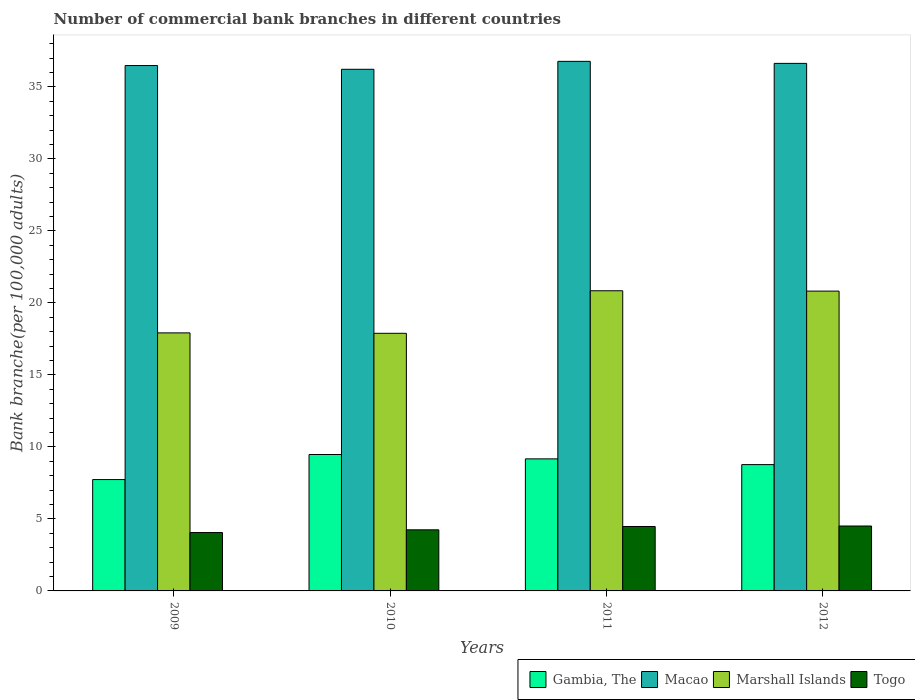How many different coloured bars are there?
Provide a succinct answer. 4. Are the number of bars per tick equal to the number of legend labels?
Your answer should be compact. Yes. How many bars are there on the 4th tick from the left?
Your response must be concise. 4. How many bars are there on the 1st tick from the right?
Give a very brief answer. 4. What is the label of the 4th group of bars from the left?
Make the answer very short. 2012. What is the number of commercial bank branches in Marshall Islands in 2009?
Provide a succinct answer. 17.92. Across all years, what is the maximum number of commercial bank branches in Macao?
Your answer should be compact. 36.77. Across all years, what is the minimum number of commercial bank branches in Marshall Islands?
Ensure brevity in your answer.  17.89. In which year was the number of commercial bank branches in Gambia, The maximum?
Make the answer very short. 2010. In which year was the number of commercial bank branches in Marshall Islands minimum?
Keep it short and to the point. 2010. What is the total number of commercial bank branches in Marshall Islands in the graph?
Provide a succinct answer. 77.46. What is the difference between the number of commercial bank branches in Macao in 2011 and that in 2012?
Your answer should be very brief. 0.14. What is the difference between the number of commercial bank branches in Macao in 2011 and the number of commercial bank branches in Togo in 2010?
Your response must be concise. 32.53. What is the average number of commercial bank branches in Gambia, The per year?
Offer a very short reply. 8.79. In the year 2012, what is the difference between the number of commercial bank branches in Macao and number of commercial bank branches in Marshall Islands?
Offer a very short reply. 15.81. In how many years, is the number of commercial bank branches in Gambia, The greater than 23?
Ensure brevity in your answer.  0. What is the ratio of the number of commercial bank branches in Marshall Islands in 2011 to that in 2012?
Offer a very short reply. 1. Is the number of commercial bank branches in Marshall Islands in 2011 less than that in 2012?
Offer a terse response. No. Is the difference between the number of commercial bank branches in Macao in 2010 and 2012 greater than the difference between the number of commercial bank branches in Marshall Islands in 2010 and 2012?
Offer a terse response. Yes. What is the difference between the highest and the second highest number of commercial bank branches in Macao?
Your answer should be compact. 0.14. What is the difference between the highest and the lowest number of commercial bank branches in Gambia, The?
Give a very brief answer. 1.74. Is the sum of the number of commercial bank branches in Togo in 2009 and 2011 greater than the maximum number of commercial bank branches in Macao across all years?
Give a very brief answer. No. What does the 2nd bar from the left in 2010 represents?
Offer a terse response. Macao. What does the 2nd bar from the right in 2011 represents?
Your answer should be very brief. Marshall Islands. How many bars are there?
Keep it short and to the point. 16. What is the difference between two consecutive major ticks on the Y-axis?
Make the answer very short. 5. Are the values on the major ticks of Y-axis written in scientific E-notation?
Ensure brevity in your answer.  No. Does the graph contain any zero values?
Offer a very short reply. No. Does the graph contain grids?
Provide a succinct answer. No. How many legend labels are there?
Provide a succinct answer. 4. How are the legend labels stacked?
Offer a terse response. Horizontal. What is the title of the graph?
Your answer should be compact. Number of commercial bank branches in different countries. Does "Belize" appear as one of the legend labels in the graph?
Ensure brevity in your answer.  No. What is the label or title of the X-axis?
Keep it short and to the point. Years. What is the label or title of the Y-axis?
Ensure brevity in your answer.  Bank branche(per 100,0 adults). What is the Bank branche(per 100,000 adults) in Gambia, The in 2009?
Provide a succinct answer. 7.73. What is the Bank branche(per 100,000 adults) in Macao in 2009?
Provide a succinct answer. 36.48. What is the Bank branche(per 100,000 adults) of Marshall Islands in 2009?
Keep it short and to the point. 17.92. What is the Bank branche(per 100,000 adults) of Togo in 2009?
Offer a very short reply. 4.05. What is the Bank branche(per 100,000 adults) in Gambia, The in 2010?
Ensure brevity in your answer.  9.47. What is the Bank branche(per 100,000 adults) of Macao in 2010?
Your response must be concise. 36.22. What is the Bank branche(per 100,000 adults) of Marshall Islands in 2010?
Offer a terse response. 17.89. What is the Bank branche(per 100,000 adults) of Togo in 2010?
Your answer should be very brief. 4.24. What is the Bank branche(per 100,000 adults) in Gambia, The in 2011?
Your response must be concise. 9.17. What is the Bank branche(per 100,000 adults) in Macao in 2011?
Keep it short and to the point. 36.77. What is the Bank branche(per 100,000 adults) in Marshall Islands in 2011?
Give a very brief answer. 20.84. What is the Bank branche(per 100,000 adults) of Togo in 2011?
Your response must be concise. 4.47. What is the Bank branche(per 100,000 adults) of Gambia, The in 2012?
Offer a terse response. 8.77. What is the Bank branche(per 100,000 adults) of Macao in 2012?
Make the answer very short. 36.63. What is the Bank branche(per 100,000 adults) of Marshall Islands in 2012?
Your answer should be compact. 20.82. What is the Bank branche(per 100,000 adults) in Togo in 2012?
Provide a short and direct response. 4.51. Across all years, what is the maximum Bank branche(per 100,000 adults) in Gambia, The?
Make the answer very short. 9.47. Across all years, what is the maximum Bank branche(per 100,000 adults) of Macao?
Provide a short and direct response. 36.77. Across all years, what is the maximum Bank branche(per 100,000 adults) of Marshall Islands?
Provide a succinct answer. 20.84. Across all years, what is the maximum Bank branche(per 100,000 adults) of Togo?
Your response must be concise. 4.51. Across all years, what is the minimum Bank branche(per 100,000 adults) of Gambia, The?
Offer a very short reply. 7.73. Across all years, what is the minimum Bank branche(per 100,000 adults) in Macao?
Ensure brevity in your answer.  36.22. Across all years, what is the minimum Bank branche(per 100,000 adults) in Marshall Islands?
Your answer should be compact. 17.89. Across all years, what is the minimum Bank branche(per 100,000 adults) of Togo?
Provide a succinct answer. 4.05. What is the total Bank branche(per 100,000 adults) of Gambia, The in the graph?
Your answer should be very brief. 35.15. What is the total Bank branche(per 100,000 adults) of Macao in the graph?
Keep it short and to the point. 146.1. What is the total Bank branche(per 100,000 adults) in Marshall Islands in the graph?
Make the answer very short. 77.46. What is the total Bank branche(per 100,000 adults) in Togo in the graph?
Ensure brevity in your answer.  17.28. What is the difference between the Bank branche(per 100,000 adults) in Gambia, The in 2009 and that in 2010?
Make the answer very short. -1.74. What is the difference between the Bank branche(per 100,000 adults) of Macao in 2009 and that in 2010?
Offer a terse response. 0.26. What is the difference between the Bank branche(per 100,000 adults) of Marshall Islands in 2009 and that in 2010?
Offer a terse response. 0.03. What is the difference between the Bank branche(per 100,000 adults) in Togo in 2009 and that in 2010?
Provide a short and direct response. -0.19. What is the difference between the Bank branche(per 100,000 adults) in Gambia, The in 2009 and that in 2011?
Provide a succinct answer. -1.44. What is the difference between the Bank branche(per 100,000 adults) in Macao in 2009 and that in 2011?
Make the answer very short. -0.29. What is the difference between the Bank branche(per 100,000 adults) of Marshall Islands in 2009 and that in 2011?
Your answer should be compact. -2.92. What is the difference between the Bank branche(per 100,000 adults) in Togo in 2009 and that in 2011?
Your answer should be compact. -0.42. What is the difference between the Bank branche(per 100,000 adults) in Gambia, The in 2009 and that in 2012?
Your answer should be very brief. -1.04. What is the difference between the Bank branche(per 100,000 adults) of Macao in 2009 and that in 2012?
Provide a succinct answer. -0.15. What is the difference between the Bank branche(per 100,000 adults) of Marshall Islands in 2009 and that in 2012?
Provide a succinct answer. -2.9. What is the difference between the Bank branche(per 100,000 adults) of Togo in 2009 and that in 2012?
Offer a terse response. -0.45. What is the difference between the Bank branche(per 100,000 adults) of Gambia, The in 2010 and that in 2011?
Offer a very short reply. 0.3. What is the difference between the Bank branche(per 100,000 adults) of Macao in 2010 and that in 2011?
Keep it short and to the point. -0.55. What is the difference between the Bank branche(per 100,000 adults) of Marshall Islands in 2010 and that in 2011?
Your answer should be very brief. -2.95. What is the difference between the Bank branche(per 100,000 adults) in Togo in 2010 and that in 2011?
Ensure brevity in your answer.  -0.23. What is the difference between the Bank branche(per 100,000 adults) of Gambia, The in 2010 and that in 2012?
Provide a short and direct response. 0.7. What is the difference between the Bank branche(per 100,000 adults) of Macao in 2010 and that in 2012?
Your answer should be compact. -0.41. What is the difference between the Bank branche(per 100,000 adults) in Marshall Islands in 2010 and that in 2012?
Your answer should be very brief. -2.93. What is the difference between the Bank branche(per 100,000 adults) in Togo in 2010 and that in 2012?
Offer a very short reply. -0.26. What is the difference between the Bank branche(per 100,000 adults) of Gambia, The in 2011 and that in 2012?
Ensure brevity in your answer.  0.4. What is the difference between the Bank branche(per 100,000 adults) of Macao in 2011 and that in 2012?
Your response must be concise. 0.14. What is the difference between the Bank branche(per 100,000 adults) in Marshall Islands in 2011 and that in 2012?
Your answer should be very brief. 0.02. What is the difference between the Bank branche(per 100,000 adults) of Togo in 2011 and that in 2012?
Your answer should be very brief. -0.03. What is the difference between the Bank branche(per 100,000 adults) in Gambia, The in 2009 and the Bank branche(per 100,000 adults) in Macao in 2010?
Offer a terse response. -28.49. What is the difference between the Bank branche(per 100,000 adults) in Gambia, The in 2009 and the Bank branche(per 100,000 adults) in Marshall Islands in 2010?
Give a very brief answer. -10.15. What is the difference between the Bank branche(per 100,000 adults) in Gambia, The in 2009 and the Bank branche(per 100,000 adults) in Togo in 2010?
Ensure brevity in your answer.  3.49. What is the difference between the Bank branche(per 100,000 adults) of Macao in 2009 and the Bank branche(per 100,000 adults) of Marshall Islands in 2010?
Ensure brevity in your answer.  18.59. What is the difference between the Bank branche(per 100,000 adults) of Macao in 2009 and the Bank branche(per 100,000 adults) of Togo in 2010?
Keep it short and to the point. 32.24. What is the difference between the Bank branche(per 100,000 adults) of Marshall Islands in 2009 and the Bank branche(per 100,000 adults) of Togo in 2010?
Offer a terse response. 13.67. What is the difference between the Bank branche(per 100,000 adults) in Gambia, The in 2009 and the Bank branche(per 100,000 adults) in Macao in 2011?
Provide a short and direct response. -29.04. What is the difference between the Bank branche(per 100,000 adults) of Gambia, The in 2009 and the Bank branche(per 100,000 adults) of Marshall Islands in 2011?
Your answer should be compact. -13.11. What is the difference between the Bank branche(per 100,000 adults) of Gambia, The in 2009 and the Bank branche(per 100,000 adults) of Togo in 2011?
Offer a terse response. 3.26. What is the difference between the Bank branche(per 100,000 adults) of Macao in 2009 and the Bank branche(per 100,000 adults) of Marshall Islands in 2011?
Make the answer very short. 15.64. What is the difference between the Bank branche(per 100,000 adults) of Macao in 2009 and the Bank branche(per 100,000 adults) of Togo in 2011?
Offer a terse response. 32.01. What is the difference between the Bank branche(per 100,000 adults) of Marshall Islands in 2009 and the Bank branche(per 100,000 adults) of Togo in 2011?
Give a very brief answer. 13.44. What is the difference between the Bank branche(per 100,000 adults) in Gambia, The in 2009 and the Bank branche(per 100,000 adults) in Macao in 2012?
Give a very brief answer. -28.9. What is the difference between the Bank branche(per 100,000 adults) of Gambia, The in 2009 and the Bank branche(per 100,000 adults) of Marshall Islands in 2012?
Offer a terse response. -13.08. What is the difference between the Bank branche(per 100,000 adults) of Gambia, The in 2009 and the Bank branche(per 100,000 adults) of Togo in 2012?
Provide a short and direct response. 3.23. What is the difference between the Bank branche(per 100,000 adults) of Macao in 2009 and the Bank branche(per 100,000 adults) of Marshall Islands in 2012?
Make the answer very short. 15.66. What is the difference between the Bank branche(per 100,000 adults) of Macao in 2009 and the Bank branche(per 100,000 adults) of Togo in 2012?
Offer a very short reply. 31.97. What is the difference between the Bank branche(per 100,000 adults) in Marshall Islands in 2009 and the Bank branche(per 100,000 adults) in Togo in 2012?
Your answer should be compact. 13.41. What is the difference between the Bank branche(per 100,000 adults) in Gambia, The in 2010 and the Bank branche(per 100,000 adults) in Macao in 2011?
Give a very brief answer. -27.3. What is the difference between the Bank branche(per 100,000 adults) in Gambia, The in 2010 and the Bank branche(per 100,000 adults) in Marshall Islands in 2011?
Make the answer very short. -11.37. What is the difference between the Bank branche(per 100,000 adults) in Gambia, The in 2010 and the Bank branche(per 100,000 adults) in Togo in 2011?
Give a very brief answer. 5. What is the difference between the Bank branche(per 100,000 adults) of Macao in 2010 and the Bank branche(per 100,000 adults) of Marshall Islands in 2011?
Your answer should be compact. 15.38. What is the difference between the Bank branche(per 100,000 adults) of Macao in 2010 and the Bank branche(per 100,000 adults) of Togo in 2011?
Keep it short and to the point. 31.75. What is the difference between the Bank branche(per 100,000 adults) of Marshall Islands in 2010 and the Bank branche(per 100,000 adults) of Togo in 2011?
Offer a very short reply. 13.41. What is the difference between the Bank branche(per 100,000 adults) in Gambia, The in 2010 and the Bank branche(per 100,000 adults) in Macao in 2012?
Make the answer very short. -27.16. What is the difference between the Bank branche(per 100,000 adults) of Gambia, The in 2010 and the Bank branche(per 100,000 adults) of Marshall Islands in 2012?
Your response must be concise. -11.35. What is the difference between the Bank branche(per 100,000 adults) of Gambia, The in 2010 and the Bank branche(per 100,000 adults) of Togo in 2012?
Make the answer very short. 4.96. What is the difference between the Bank branche(per 100,000 adults) of Macao in 2010 and the Bank branche(per 100,000 adults) of Marshall Islands in 2012?
Your answer should be very brief. 15.4. What is the difference between the Bank branche(per 100,000 adults) of Macao in 2010 and the Bank branche(per 100,000 adults) of Togo in 2012?
Your response must be concise. 31.71. What is the difference between the Bank branche(per 100,000 adults) of Marshall Islands in 2010 and the Bank branche(per 100,000 adults) of Togo in 2012?
Offer a terse response. 13.38. What is the difference between the Bank branche(per 100,000 adults) in Gambia, The in 2011 and the Bank branche(per 100,000 adults) in Macao in 2012?
Keep it short and to the point. -27.46. What is the difference between the Bank branche(per 100,000 adults) of Gambia, The in 2011 and the Bank branche(per 100,000 adults) of Marshall Islands in 2012?
Ensure brevity in your answer.  -11.65. What is the difference between the Bank branche(per 100,000 adults) of Gambia, The in 2011 and the Bank branche(per 100,000 adults) of Togo in 2012?
Offer a terse response. 4.66. What is the difference between the Bank branche(per 100,000 adults) of Macao in 2011 and the Bank branche(per 100,000 adults) of Marshall Islands in 2012?
Make the answer very short. 15.95. What is the difference between the Bank branche(per 100,000 adults) in Macao in 2011 and the Bank branche(per 100,000 adults) in Togo in 2012?
Make the answer very short. 32.26. What is the difference between the Bank branche(per 100,000 adults) of Marshall Islands in 2011 and the Bank branche(per 100,000 adults) of Togo in 2012?
Give a very brief answer. 16.33. What is the average Bank branche(per 100,000 adults) in Gambia, The per year?
Ensure brevity in your answer.  8.79. What is the average Bank branche(per 100,000 adults) of Macao per year?
Provide a short and direct response. 36.52. What is the average Bank branche(per 100,000 adults) in Marshall Islands per year?
Offer a terse response. 19.37. What is the average Bank branche(per 100,000 adults) of Togo per year?
Offer a very short reply. 4.32. In the year 2009, what is the difference between the Bank branche(per 100,000 adults) of Gambia, The and Bank branche(per 100,000 adults) of Macao?
Your response must be concise. -28.75. In the year 2009, what is the difference between the Bank branche(per 100,000 adults) in Gambia, The and Bank branche(per 100,000 adults) in Marshall Islands?
Ensure brevity in your answer.  -10.18. In the year 2009, what is the difference between the Bank branche(per 100,000 adults) of Gambia, The and Bank branche(per 100,000 adults) of Togo?
Give a very brief answer. 3.68. In the year 2009, what is the difference between the Bank branche(per 100,000 adults) in Macao and Bank branche(per 100,000 adults) in Marshall Islands?
Your response must be concise. 18.56. In the year 2009, what is the difference between the Bank branche(per 100,000 adults) in Macao and Bank branche(per 100,000 adults) in Togo?
Offer a very short reply. 32.43. In the year 2009, what is the difference between the Bank branche(per 100,000 adults) in Marshall Islands and Bank branche(per 100,000 adults) in Togo?
Ensure brevity in your answer.  13.86. In the year 2010, what is the difference between the Bank branche(per 100,000 adults) of Gambia, The and Bank branche(per 100,000 adults) of Macao?
Provide a succinct answer. -26.75. In the year 2010, what is the difference between the Bank branche(per 100,000 adults) in Gambia, The and Bank branche(per 100,000 adults) in Marshall Islands?
Offer a very short reply. -8.42. In the year 2010, what is the difference between the Bank branche(per 100,000 adults) of Gambia, The and Bank branche(per 100,000 adults) of Togo?
Offer a terse response. 5.23. In the year 2010, what is the difference between the Bank branche(per 100,000 adults) of Macao and Bank branche(per 100,000 adults) of Marshall Islands?
Provide a succinct answer. 18.33. In the year 2010, what is the difference between the Bank branche(per 100,000 adults) in Macao and Bank branche(per 100,000 adults) in Togo?
Keep it short and to the point. 31.98. In the year 2010, what is the difference between the Bank branche(per 100,000 adults) in Marshall Islands and Bank branche(per 100,000 adults) in Togo?
Offer a terse response. 13.64. In the year 2011, what is the difference between the Bank branche(per 100,000 adults) of Gambia, The and Bank branche(per 100,000 adults) of Macao?
Ensure brevity in your answer.  -27.6. In the year 2011, what is the difference between the Bank branche(per 100,000 adults) in Gambia, The and Bank branche(per 100,000 adults) in Marshall Islands?
Provide a short and direct response. -11.67. In the year 2011, what is the difference between the Bank branche(per 100,000 adults) in Gambia, The and Bank branche(per 100,000 adults) in Togo?
Your response must be concise. 4.7. In the year 2011, what is the difference between the Bank branche(per 100,000 adults) in Macao and Bank branche(per 100,000 adults) in Marshall Islands?
Your response must be concise. 15.93. In the year 2011, what is the difference between the Bank branche(per 100,000 adults) of Macao and Bank branche(per 100,000 adults) of Togo?
Offer a terse response. 32.3. In the year 2011, what is the difference between the Bank branche(per 100,000 adults) of Marshall Islands and Bank branche(per 100,000 adults) of Togo?
Ensure brevity in your answer.  16.37. In the year 2012, what is the difference between the Bank branche(per 100,000 adults) in Gambia, The and Bank branche(per 100,000 adults) in Macao?
Provide a succinct answer. -27.86. In the year 2012, what is the difference between the Bank branche(per 100,000 adults) in Gambia, The and Bank branche(per 100,000 adults) in Marshall Islands?
Ensure brevity in your answer.  -12.05. In the year 2012, what is the difference between the Bank branche(per 100,000 adults) in Gambia, The and Bank branche(per 100,000 adults) in Togo?
Make the answer very short. 4.26. In the year 2012, what is the difference between the Bank branche(per 100,000 adults) of Macao and Bank branche(per 100,000 adults) of Marshall Islands?
Offer a very short reply. 15.81. In the year 2012, what is the difference between the Bank branche(per 100,000 adults) in Macao and Bank branche(per 100,000 adults) in Togo?
Your response must be concise. 32.12. In the year 2012, what is the difference between the Bank branche(per 100,000 adults) in Marshall Islands and Bank branche(per 100,000 adults) in Togo?
Your answer should be compact. 16.31. What is the ratio of the Bank branche(per 100,000 adults) in Gambia, The in 2009 to that in 2010?
Provide a succinct answer. 0.82. What is the ratio of the Bank branche(per 100,000 adults) in Togo in 2009 to that in 2010?
Your answer should be compact. 0.96. What is the ratio of the Bank branche(per 100,000 adults) in Gambia, The in 2009 to that in 2011?
Provide a succinct answer. 0.84. What is the ratio of the Bank branche(per 100,000 adults) of Marshall Islands in 2009 to that in 2011?
Make the answer very short. 0.86. What is the ratio of the Bank branche(per 100,000 adults) in Togo in 2009 to that in 2011?
Ensure brevity in your answer.  0.91. What is the ratio of the Bank branche(per 100,000 adults) in Gambia, The in 2009 to that in 2012?
Offer a terse response. 0.88. What is the ratio of the Bank branche(per 100,000 adults) in Marshall Islands in 2009 to that in 2012?
Provide a succinct answer. 0.86. What is the ratio of the Bank branche(per 100,000 adults) in Togo in 2009 to that in 2012?
Your answer should be compact. 0.9. What is the ratio of the Bank branche(per 100,000 adults) in Gambia, The in 2010 to that in 2011?
Your answer should be very brief. 1.03. What is the ratio of the Bank branche(per 100,000 adults) of Macao in 2010 to that in 2011?
Make the answer very short. 0.98. What is the ratio of the Bank branche(per 100,000 adults) in Marshall Islands in 2010 to that in 2011?
Give a very brief answer. 0.86. What is the ratio of the Bank branche(per 100,000 adults) of Togo in 2010 to that in 2011?
Give a very brief answer. 0.95. What is the ratio of the Bank branche(per 100,000 adults) in Gambia, The in 2010 to that in 2012?
Provide a short and direct response. 1.08. What is the ratio of the Bank branche(per 100,000 adults) of Marshall Islands in 2010 to that in 2012?
Your answer should be compact. 0.86. What is the ratio of the Bank branche(per 100,000 adults) of Togo in 2010 to that in 2012?
Make the answer very short. 0.94. What is the ratio of the Bank branche(per 100,000 adults) of Gambia, The in 2011 to that in 2012?
Your response must be concise. 1.05. What is the ratio of the Bank branche(per 100,000 adults) in Marshall Islands in 2011 to that in 2012?
Offer a very short reply. 1. What is the ratio of the Bank branche(per 100,000 adults) of Togo in 2011 to that in 2012?
Make the answer very short. 0.99. What is the difference between the highest and the second highest Bank branche(per 100,000 adults) in Gambia, The?
Offer a very short reply. 0.3. What is the difference between the highest and the second highest Bank branche(per 100,000 adults) in Macao?
Ensure brevity in your answer.  0.14. What is the difference between the highest and the second highest Bank branche(per 100,000 adults) in Marshall Islands?
Keep it short and to the point. 0.02. What is the difference between the highest and the second highest Bank branche(per 100,000 adults) of Togo?
Offer a terse response. 0.03. What is the difference between the highest and the lowest Bank branche(per 100,000 adults) of Gambia, The?
Make the answer very short. 1.74. What is the difference between the highest and the lowest Bank branche(per 100,000 adults) of Macao?
Your answer should be compact. 0.55. What is the difference between the highest and the lowest Bank branche(per 100,000 adults) of Marshall Islands?
Your answer should be compact. 2.95. What is the difference between the highest and the lowest Bank branche(per 100,000 adults) of Togo?
Your answer should be very brief. 0.45. 